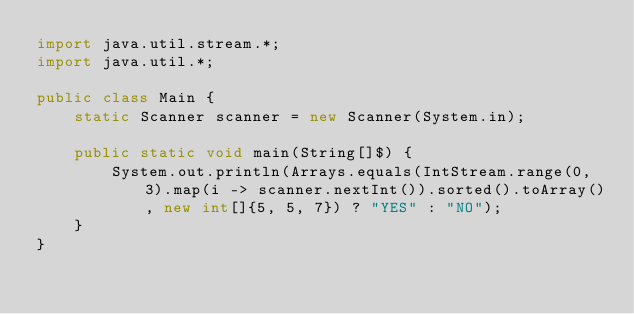<code> <loc_0><loc_0><loc_500><loc_500><_Java_>import java.util.stream.*;
import java.util.*;

public class Main {
    static Scanner scanner = new Scanner(System.in);

    public static void main(String[]$) {
        System.out.println(Arrays.equals(IntStream.range(0, 3).map(i -> scanner.nextInt()).sorted().toArray(), new int[]{5, 5, 7}) ? "YES" : "NO");
    }
}</code> 